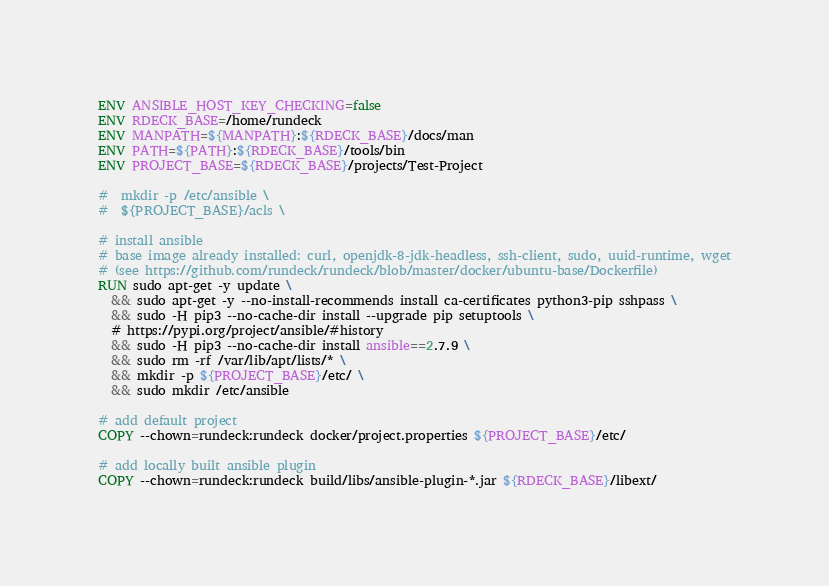Convert code to text. <code><loc_0><loc_0><loc_500><loc_500><_Dockerfile_>
ENV ANSIBLE_HOST_KEY_CHECKING=false
ENV RDECK_BASE=/home/rundeck
ENV MANPATH=${MANPATH}:${RDECK_BASE}/docs/man
ENV PATH=${PATH}:${RDECK_BASE}/tools/bin
ENV PROJECT_BASE=${RDECK_BASE}/projects/Test-Project

#  mkdir -p /etc/ansible \
#  ${PROJECT_BASE}/acls \

# install ansible
# base image already installed: curl, openjdk-8-jdk-headless, ssh-client, sudo, uuid-runtime, wget
# (see https://github.com/rundeck/rundeck/blob/master/docker/ubuntu-base/Dockerfile)
RUN sudo apt-get -y update \
  && sudo apt-get -y --no-install-recommends install ca-certificates python3-pip sshpass \
  && sudo -H pip3 --no-cache-dir install --upgrade pip setuptools \
  # https://pypi.org/project/ansible/#history
  && sudo -H pip3 --no-cache-dir install ansible==2.7.9 \
  && sudo rm -rf /var/lib/apt/lists/* \
  && mkdir -p ${PROJECT_BASE}/etc/ \
  && sudo mkdir /etc/ansible

# add default project
COPY --chown=rundeck:rundeck docker/project.properties ${PROJECT_BASE}/etc/

# add locally built ansible plugin
COPY --chown=rundeck:rundeck build/libs/ansible-plugin-*.jar ${RDECK_BASE}/libext/
</code> 